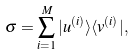Convert formula to latex. <formula><loc_0><loc_0><loc_500><loc_500>\sigma = \sum _ { i = 1 } ^ { M } | u ^ { ( i ) } \rangle \langle v ^ { ( i ) } | ,</formula> 